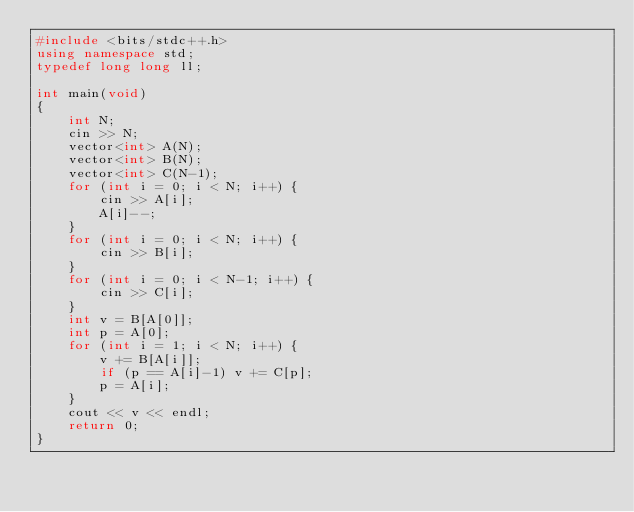<code> <loc_0><loc_0><loc_500><loc_500><_C++_>#include <bits/stdc++.h>
using namespace std;
typedef long long ll;

int main(void)
{
    int N;
    cin >> N;
    vector<int> A(N);
    vector<int> B(N);
    vector<int> C(N-1);
    for (int i = 0; i < N; i++) {
        cin >> A[i];
        A[i]--;
    }
    for (int i = 0; i < N; i++) {
        cin >> B[i];
    }
    for (int i = 0; i < N-1; i++) {
        cin >> C[i];
    }
    int v = B[A[0]];
    int p = A[0];
    for (int i = 1; i < N; i++) {
        v += B[A[i]];
        if (p == A[i]-1) v += C[p];
        p = A[i];
    }
    cout << v << endl;
    return 0;
}

</code> 